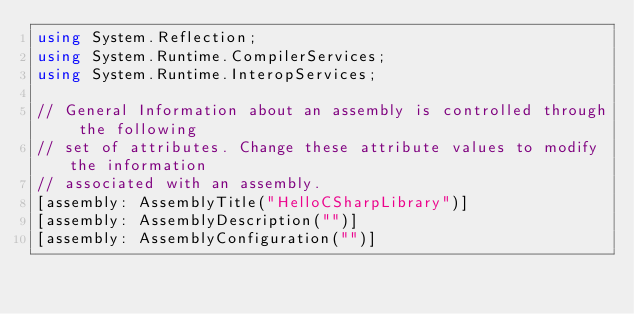Convert code to text. <code><loc_0><loc_0><loc_500><loc_500><_C#_>using System.Reflection;
using System.Runtime.CompilerServices;
using System.Runtime.InteropServices;

// General Information about an assembly is controlled through the following 
// set of attributes. Change these attribute values to modify the information
// associated with an assembly.
[assembly: AssemblyTitle("HelloCSharpLibrary")]
[assembly: AssemblyDescription("")]
[assembly: AssemblyConfiguration("")]</code> 